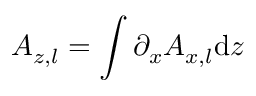Convert formula to latex. <formula><loc_0><loc_0><loc_500><loc_500>A _ { z , l } = \int \partial _ { x } A _ { x , l } d z</formula> 